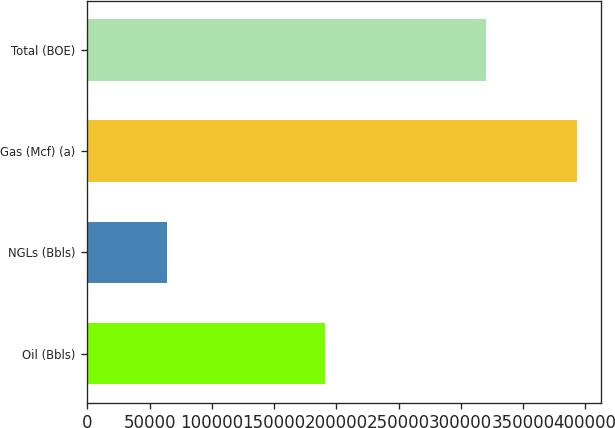Convert chart to OTSL. <chart><loc_0><loc_0><loc_500><loc_500><bar_chart><fcel>Oil (Bbls)<fcel>NGLs (Bbls)<fcel>Gas (Mcf) (a)<fcel>Total (BOE)<nl><fcel>190639<fcel>63780<fcel>393391<fcel>319984<nl></chart> 